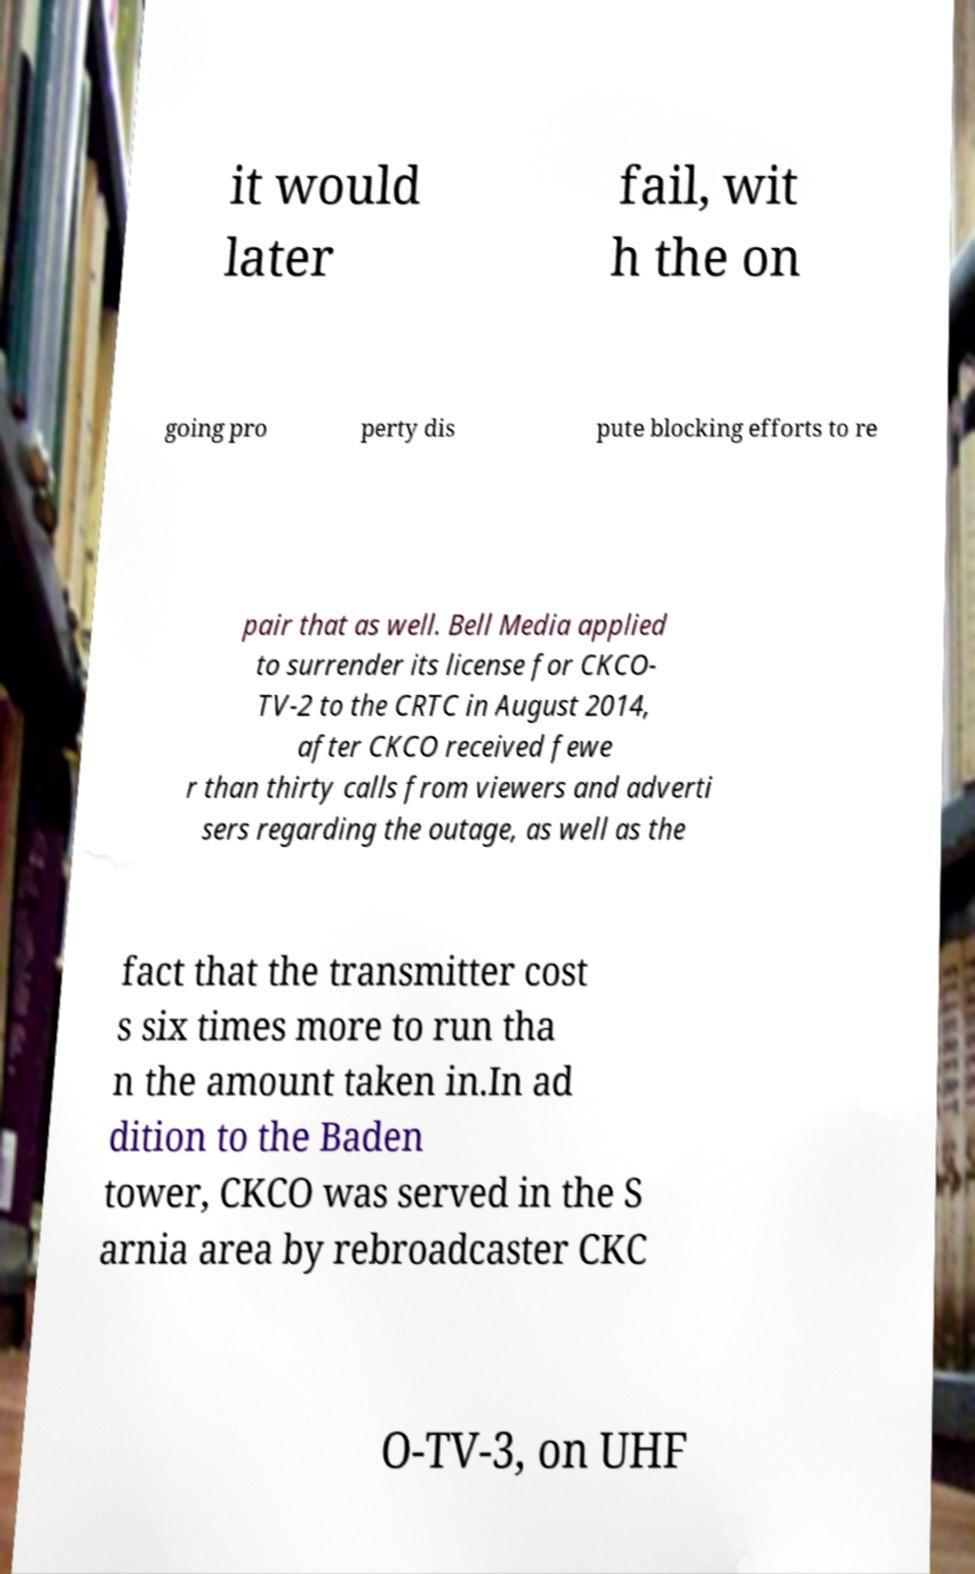Could you assist in decoding the text presented in this image and type it out clearly? it would later fail, wit h the on going pro perty dis pute blocking efforts to re pair that as well. Bell Media applied to surrender its license for CKCO- TV-2 to the CRTC in August 2014, after CKCO received fewe r than thirty calls from viewers and adverti sers regarding the outage, as well as the fact that the transmitter cost s six times more to run tha n the amount taken in.In ad dition to the Baden tower, CKCO was served in the S arnia area by rebroadcaster CKC O-TV-3, on UHF 